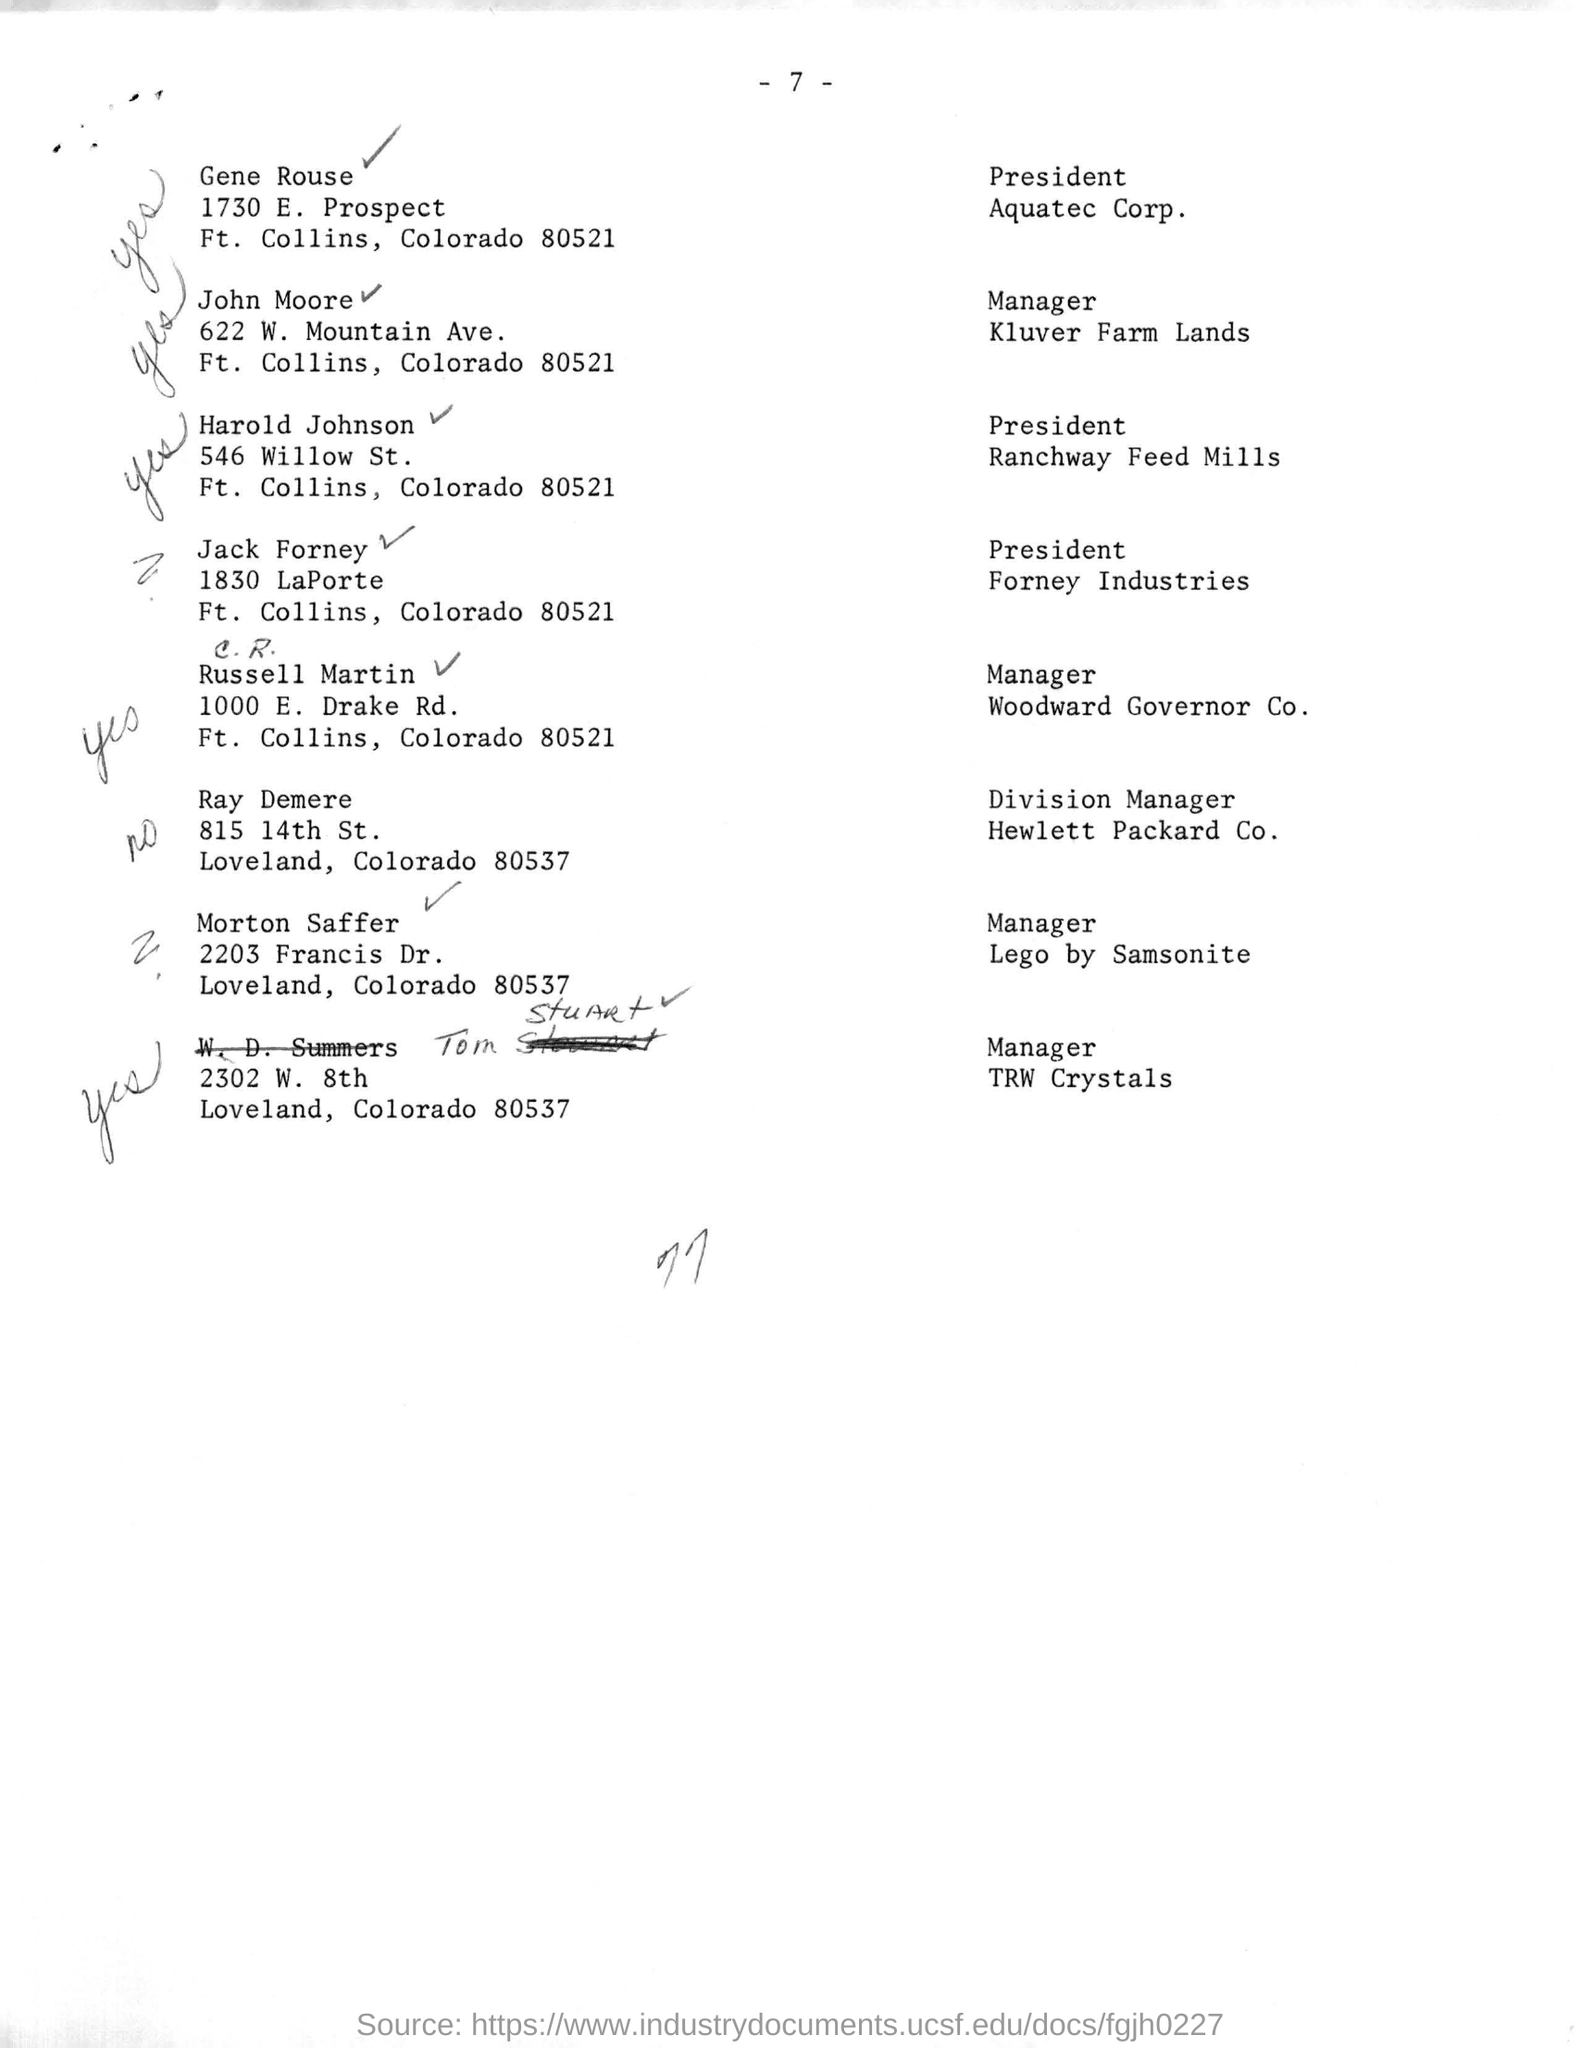Who is the president of Aquatec Corp.?
Provide a short and direct response. Gene Rouse. What is the designation of Ray Demere?
Your answer should be very brief. Division Manager. What is the postal code of Loveland?
Your answer should be very brief. 80537. 